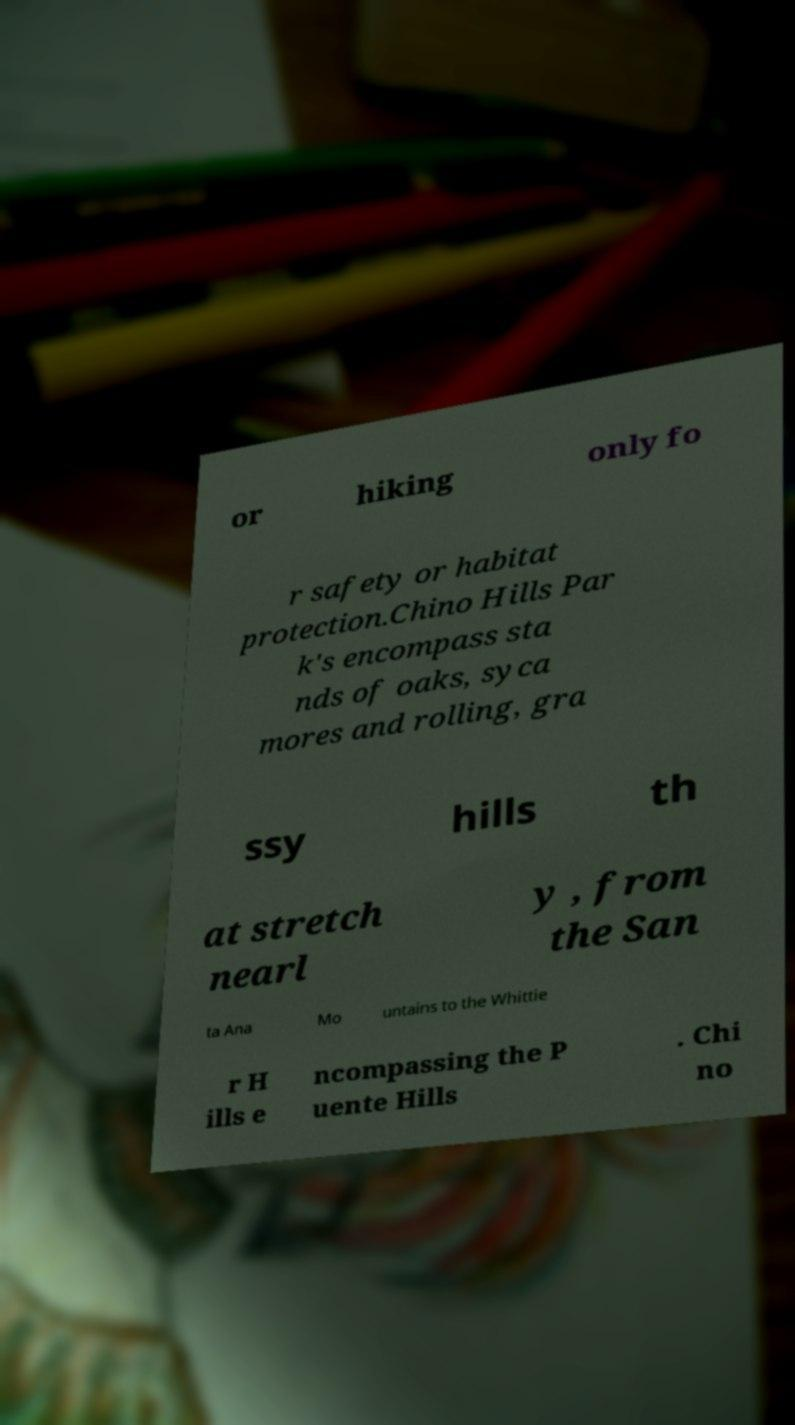For documentation purposes, I need the text within this image transcribed. Could you provide that? or hiking only fo r safety or habitat protection.Chino Hills Par k's encompass sta nds of oaks, syca mores and rolling, gra ssy hills th at stretch nearl y , from the San ta Ana Mo untains to the Whittie r H ills e ncompassing the P uente Hills . Chi no 